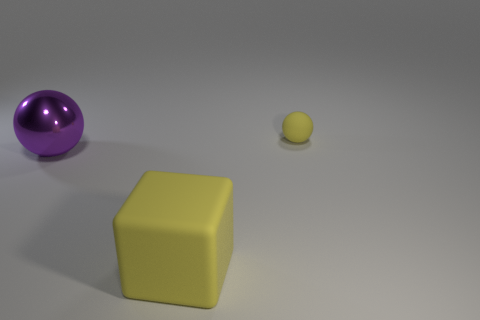Does the matte ball have the same color as the large object in front of the metal ball?
Your answer should be compact. Yes. How many big blue cylinders are there?
Your response must be concise. 0. What number of things are either small purple things or matte balls?
Ensure brevity in your answer.  1. There is a rubber object that is the same color as the block; what is its size?
Your response must be concise. Small. Are there any yellow blocks left of the big metallic sphere?
Ensure brevity in your answer.  No. Is the number of shiny objects that are behind the tiny matte thing greater than the number of rubber things behind the large metal object?
Your answer should be compact. No. What is the size of the other shiny thing that is the same shape as the tiny object?
Make the answer very short. Large. How many cylinders are either large yellow rubber things or small yellow objects?
Ensure brevity in your answer.  0. What is the material of the ball that is the same color as the large matte cube?
Your answer should be very brief. Rubber. Are there fewer metallic spheres right of the metal sphere than big yellow things left of the yellow matte ball?
Provide a succinct answer. Yes. 